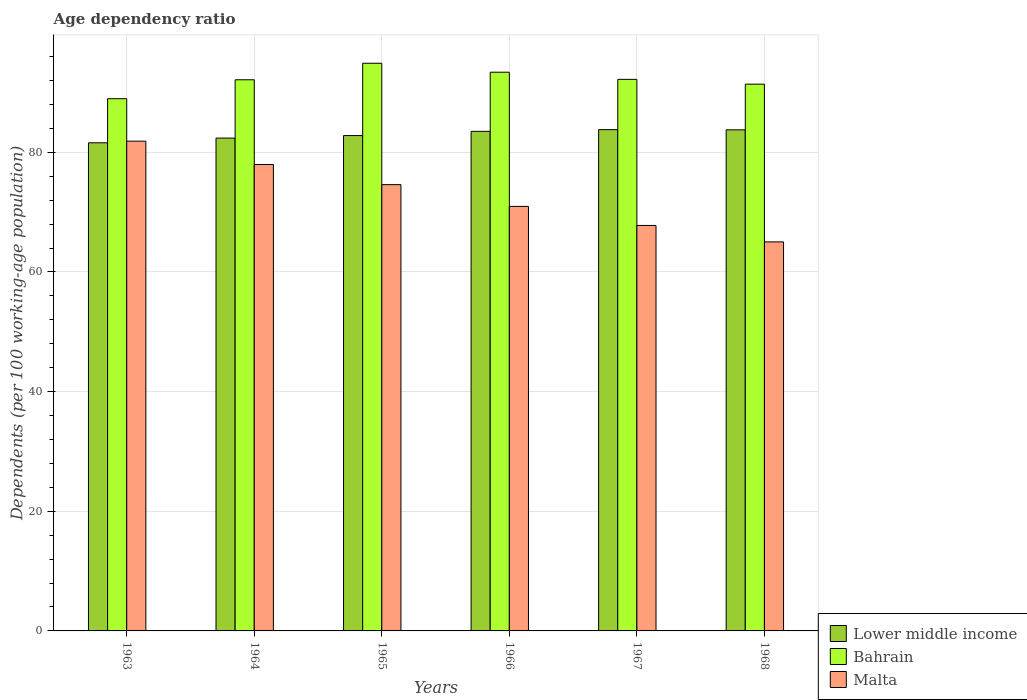How many different coloured bars are there?
Offer a very short reply. 3. How many bars are there on the 5th tick from the right?
Give a very brief answer. 3. What is the label of the 4th group of bars from the left?
Offer a terse response. 1966. What is the age dependency ratio in in Lower middle income in 1967?
Offer a very short reply. 83.79. Across all years, what is the maximum age dependency ratio in in Lower middle income?
Your response must be concise. 83.79. Across all years, what is the minimum age dependency ratio in in Lower middle income?
Keep it short and to the point. 81.59. In which year was the age dependency ratio in in Lower middle income maximum?
Make the answer very short. 1967. What is the total age dependency ratio in in Malta in the graph?
Your answer should be very brief. 438.16. What is the difference between the age dependency ratio in in Bahrain in 1963 and that in 1965?
Give a very brief answer. -5.93. What is the difference between the age dependency ratio in in Malta in 1968 and the age dependency ratio in in Bahrain in 1963?
Your answer should be compact. -23.93. What is the average age dependency ratio in in Malta per year?
Offer a terse response. 73.03. In the year 1964, what is the difference between the age dependency ratio in in Malta and age dependency ratio in in Lower middle income?
Offer a very short reply. -4.41. What is the ratio of the age dependency ratio in in Lower middle income in 1967 to that in 1968?
Make the answer very short. 1. What is the difference between the highest and the second highest age dependency ratio in in Bahrain?
Offer a very short reply. 1.5. What is the difference between the highest and the lowest age dependency ratio in in Malta?
Keep it short and to the point. 16.84. In how many years, is the age dependency ratio in in Lower middle income greater than the average age dependency ratio in in Lower middle income taken over all years?
Make the answer very short. 3. Is the sum of the age dependency ratio in in Lower middle income in 1965 and 1966 greater than the maximum age dependency ratio in in Bahrain across all years?
Provide a succinct answer. Yes. What does the 2nd bar from the left in 1965 represents?
Provide a succinct answer. Bahrain. What does the 3rd bar from the right in 1966 represents?
Ensure brevity in your answer.  Lower middle income. Are all the bars in the graph horizontal?
Make the answer very short. No. What is the difference between two consecutive major ticks on the Y-axis?
Make the answer very short. 20. Does the graph contain grids?
Provide a succinct answer. Yes. How are the legend labels stacked?
Offer a very short reply. Vertical. What is the title of the graph?
Your response must be concise. Age dependency ratio. Does "Morocco" appear as one of the legend labels in the graph?
Your answer should be very brief. No. What is the label or title of the Y-axis?
Keep it short and to the point. Dependents (per 100 working-age population). What is the Dependents (per 100 working-age population) of Lower middle income in 1963?
Give a very brief answer. 81.59. What is the Dependents (per 100 working-age population) of Bahrain in 1963?
Make the answer very short. 88.95. What is the Dependents (per 100 working-age population) in Malta in 1963?
Offer a terse response. 81.86. What is the Dependents (per 100 working-age population) in Lower middle income in 1964?
Provide a succinct answer. 82.37. What is the Dependents (per 100 working-age population) of Bahrain in 1964?
Ensure brevity in your answer.  92.12. What is the Dependents (per 100 working-age population) of Malta in 1964?
Provide a succinct answer. 77.96. What is the Dependents (per 100 working-age population) in Lower middle income in 1965?
Ensure brevity in your answer.  82.79. What is the Dependents (per 100 working-age population) in Bahrain in 1965?
Keep it short and to the point. 94.88. What is the Dependents (per 100 working-age population) of Malta in 1965?
Make the answer very short. 74.59. What is the Dependents (per 100 working-age population) of Lower middle income in 1966?
Your response must be concise. 83.5. What is the Dependents (per 100 working-age population) of Bahrain in 1966?
Offer a terse response. 93.38. What is the Dependents (per 100 working-age population) of Malta in 1966?
Offer a very short reply. 70.96. What is the Dependents (per 100 working-age population) in Lower middle income in 1967?
Make the answer very short. 83.79. What is the Dependents (per 100 working-age population) in Bahrain in 1967?
Provide a succinct answer. 92.19. What is the Dependents (per 100 working-age population) of Malta in 1967?
Make the answer very short. 67.77. What is the Dependents (per 100 working-age population) of Lower middle income in 1968?
Offer a terse response. 83.75. What is the Dependents (per 100 working-age population) in Bahrain in 1968?
Your answer should be very brief. 91.39. What is the Dependents (per 100 working-age population) of Malta in 1968?
Ensure brevity in your answer.  65.02. Across all years, what is the maximum Dependents (per 100 working-age population) of Lower middle income?
Your answer should be compact. 83.79. Across all years, what is the maximum Dependents (per 100 working-age population) in Bahrain?
Give a very brief answer. 94.88. Across all years, what is the maximum Dependents (per 100 working-age population) in Malta?
Ensure brevity in your answer.  81.86. Across all years, what is the minimum Dependents (per 100 working-age population) of Lower middle income?
Provide a short and direct response. 81.59. Across all years, what is the minimum Dependents (per 100 working-age population) in Bahrain?
Your answer should be very brief. 88.95. Across all years, what is the minimum Dependents (per 100 working-age population) in Malta?
Provide a succinct answer. 65.02. What is the total Dependents (per 100 working-age population) in Lower middle income in the graph?
Provide a succinct answer. 497.79. What is the total Dependents (per 100 working-age population) in Bahrain in the graph?
Ensure brevity in your answer.  552.91. What is the total Dependents (per 100 working-age population) of Malta in the graph?
Your answer should be compact. 438.16. What is the difference between the Dependents (per 100 working-age population) of Lower middle income in 1963 and that in 1964?
Offer a terse response. -0.79. What is the difference between the Dependents (per 100 working-age population) in Bahrain in 1963 and that in 1964?
Your answer should be very brief. -3.17. What is the difference between the Dependents (per 100 working-age population) of Malta in 1963 and that in 1964?
Give a very brief answer. 3.9. What is the difference between the Dependents (per 100 working-age population) of Lower middle income in 1963 and that in 1965?
Give a very brief answer. -1.21. What is the difference between the Dependents (per 100 working-age population) in Bahrain in 1963 and that in 1965?
Ensure brevity in your answer.  -5.93. What is the difference between the Dependents (per 100 working-age population) in Malta in 1963 and that in 1965?
Make the answer very short. 7.27. What is the difference between the Dependents (per 100 working-age population) of Lower middle income in 1963 and that in 1966?
Ensure brevity in your answer.  -1.91. What is the difference between the Dependents (per 100 working-age population) in Bahrain in 1963 and that in 1966?
Keep it short and to the point. -4.43. What is the difference between the Dependents (per 100 working-age population) of Malta in 1963 and that in 1966?
Provide a short and direct response. 10.9. What is the difference between the Dependents (per 100 working-age population) in Lower middle income in 1963 and that in 1967?
Your answer should be very brief. -2.2. What is the difference between the Dependents (per 100 working-age population) of Bahrain in 1963 and that in 1967?
Make the answer very short. -3.24. What is the difference between the Dependents (per 100 working-age population) of Malta in 1963 and that in 1967?
Provide a short and direct response. 14.09. What is the difference between the Dependents (per 100 working-age population) of Lower middle income in 1963 and that in 1968?
Offer a very short reply. -2.17. What is the difference between the Dependents (per 100 working-age population) of Bahrain in 1963 and that in 1968?
Your answer should be very brief. -2.43. What is the difference between the Dependents (per 100 working-age population) of Malta in 1963 and that in 1968?
Offer a terse response. 16.84. What is the difference between the Dependents (per 100 working-age population) in Lower middle income in 1964 and that in 1965?
Your response must be concise. -0.42. What is the difference between the Dependents (per 100 working-age population) of Bahrain in 1964 and that in 1965?
Provide a short and direct response. -2.76. What is the difference between the Dependents (per 100 working-age population) in Malta in 1964 and that in 1965?
Ensure brevity in your answer.  3.37. What is the difference between the Dependents (per 100 working-age population) of Lower middle income in 1964 and that in 1966?
Your response must be concise. -1.13. What is the difference between the Dependents (per 100 working-age population) in Bahrain in 1964 and that in 1966?
Ensure brevity in your answer.  -1.26. What is the difference between the Dependents (per 100 working-age population) in Malta in 1964 and that in 1966?
Keep it short and to the point. 7.01. What is the difference between the Dependents (per 100 working-age population) of Lower middle income in 1964 and that in 1967?
Your response must be concise. -1.41. What is the difference between the Dependents (per 100 working-age population) of Bahrain in 1964 and that in 1967?
Offer a very short reply. -0.07. What is the difference between the Dependents (per 100 working-age population) in Malta in 1964 and that in 1967?
Offer a very short reply. 10.19. What is the difference between the Dependents (per 100 working-age population) in Lower middle income in 1964 and that in 1968?
Your answer should be compact. -1.38. What is the difference between the Dependents (per 100 working-age population) in Bahrain in 1964 and that in 1968?
Provide a short and direct response. 0.73. What is the difference between the Dependents (per 100 working-age population) in Malta in 1964 and that in 1968?
Ensure brevity in your answer.  12.94. What is the difference between the Dependents (per 100 working-age population) of Lower middle income in 1965 and that in 1966?
Ensure brevity in your answer.  -0.71. What is the difference between the Dependents (per 100 working-age population) in Bahrain in 1965 and that in 1966?
Offer a terse response. 1.5. What is the difference between the Dependents (per 100 working-age population) in Malta in 1965 and that in 1966?
Give a very brief answer. 3.64. What is the difference between the Dependents (per 100 working-age population) of Lower middle income in 1965 and that in 1967?
Offer a terse response. -0.99. What is the difference between the Dependents (per 100 working-age population) of Bahrain in 1965 and that in 1967?
Your answer should be compact. 2.69. What is the difference between the Dependents (per 100 working-age population) in Malta in 1965 and that in 1967?
Give a very brief answer. 6.82. What is the difference between the Dependents (per 100 working-age population) in Lower middle income in 1965 and that in 1968?
Offer a very short reply. -0.96. What is the difference between the Dependents (per 100 working-age population) of Bahrain in 1965 and that in 1968?
Your response must be concise. 3.49. What is the difference between the Dependents (per 100 working-age population) in Malta in 1965 and that in 1968?
Ensure brevity in your answer.  9.57. What is the difference between the Dependents (per 100 working-age population) of Lower middle income in 1966 and that in 1967?
Ensure brevity in your answer.  -0.29. What is the difference between the Dependents (per 100 working-age population) of Bahrain in 1966 and that in 1967?
Your response must be concise. 1.19. What is the difference between the Dependents (per 100 working-age population) in Malta in 1966 and that in 1967?
Your answer should be very brief. 3.18. What is the difference between the Dependents (per 100 working-age population) of Lower middle income in 1966 and that in 1968?
Offer a very short reply. -0.25. What is the difference between the Dependents (per 100 working-age population) in Bahrain in 1966 and that in 1968?
Ensure brevity in your answer.  2. What is the difference between the Dependents (per 100 working-age population) in Malta in 1966 and that in 1968?
Your answer should be very brief. 5.93. What is the difference between the Dependents (per 100 working-age population) in Lower middle income in 1967 and that in 1968?
Provide a succinct answer. 0.04. What is the difference between the Dependents (per 100 working-age population) in Bahrain in 1967 and that in 1968?
Your response must be concise. 0.8. What is the difference between the Dependents (per 100 working-age population) of Malta in 1967 and that in 1968?
Give a very brief answer. 2.75. What is the difference between the Dependents (per 100 working-age population) of Lower middle income in 1963 and the Dependents (per 100 working-age population) of Bahrain in 1964?
Provide a succinct answer. -10.53. What is the difference between the Dependents (per 100 working-age population) of Lower middle income in 1963 and the Dependents (per 100 working-age population) of Malta in 1964?
Keep it short and to the point. 3.63. What is the difference between the Dependents (per 100 working-age population) of Bahrain in 1963 and the Dependents (per 100 working-age population) of Malta in 1964?
Offer a very short reply. 10.99. What is the difference between the Dependents (per 100 working-age population) of Lower middle income in 1963 and the Dependents (per 100 working-age population) of Bahrain in 1965?
Make the answer very short. -13.29. What is the difference between the Dependents (per 100 working-age population) in Lower middle income in 1963 and the Dependents (per 100 working-age population) in Malta in 1965?
Offer a terse response. 6.99. What is the difference between the Dependents (per 100 working-age population) of Bahrain in 1963 and the Dependents (per 100 working-age population) of Malta in 1965?
Provide a short and direct response. 14.36. What is the difference between the Dependents (per 100 working-age population) of Lower middle income in 1963 and the Dependents (per 100 working-age population) of Bahrain in 1966?
Offer a terse response. -11.8. What is the difference between the Dependents (per 100 working-age population) of Lower middle income in 1963 and the Dependents (per 100 working-age population) of Malta in 1966?
Offer a very short reply. 10.63. What is the difference between the Dependents (per 100 working-age population) in Bahrain in 1963 and the Dependents (per 100 working-age population) in Malta in 1966?
Your answer should be compact. 18. What is the difference between the Dependents (per 100 working-age population) of Lower middle income in 1963 and the Dependents (per 100 working-age population) of Bahrain in 1967?
Offer a terse response. -10.6. What is the difference between the Dependents (per 100 working-age population) in Lower middle income in 1963 and the Dependents (per 100 working-age population) in Malta in 1967?
Your answer should be very brief. 13.81. What is the difference between the Dependents (per 100 working-age population) of Bahrain in 1963 and the Dependents (per 100 working-age population) of Malta in 1967?
Your answer should be compact. 21.18. What is the difference between the Dependents (per 100 working-age population) of Lower middle income in 1963 and the Dependents (per 100 working-age population) of Bahrain in 1968?
Your answer should be very brief. -9.8. What is the difference between the Dependents (per 100 working-age population) in Lower middle income in 1963 and the Dependents (per 100 working-age population) in Malta in 1968?
Offer a terse response. 16.56. What is the difference between the Dependents (per 100 working-age population) of Bahrain in 1963 and the Dependents (per 100 working-age population) of Malta in 1968?
Offer a very short reply. 23.93. What is the difference between the Dependents (per 100 working-age population) in Lower middle income in 1964 and the Dependents (per 100 working-age population) in Bahrain in 1965?
Make the answer very short. -12.51. What is the difference between the Dependents (per 100 working-age population) in Lower middle income in 1964 and the Dependents (per 100 working-age population) in Malta in 1965?
Provide a short and direct response. 7.78. What is the difference between the Dependents (per 100 working-age population) in Bahrain in 1964 and the Dependents (per 100 working-age population) in Malta in 1965?
Make the answer very short. 17.53. What is the difference between the Dependents (per 100 working-age population) in Lower middle income in 1964 and the Dependents (per 100 working-age population) in Bahrain in 1966?
Your response must be concise. -11.01. What is the difference between the Dependents (per 100 working-age population) of Lower middle income in 1964 and the Dependents (per 100 working-age population) of Malta in 1966?
Offer a very short reply. 11.42. What is the difference between the Dependents (per 100 working-age population) in Bahrain in 1964 and the Dependents (per 100 working-age population) in Malta in 1966?
Give a very brief answer. 21.16. What is the difference between the Dependents (per 100 working-age population) of Lower middle income in 1964 and the Dependents (per 100 working-age population) of Bahrain in 1967?
Provide a succinct answer. -9.82. What is the difference between the Dependents (per 100 working-age population) of Lower middle income in 1964 and the Dependents (per 100 working-age population) of Malta in 1967?
Make the answer very short. 14.6. What is the difference between the Dependents (per 100 working-age population) of Bahrain in 1964 and the Dependents (per 100 working-age population) of Malta in 1967?
Provide a short and direct response. 24.35. What is the difference between the Dependents (per 100 working-age population) of Lower middle income in 1964 and the Dependents (per 100 working-age population) of Bahrain in 1968?
Ensure brevity in your answer.  -9.01. What is the difference between the Dependents (per 100 working-age population) of Lower middle income in 1964 and the Dependents (per 100 working-age population) of Malta in 1968?
Offer a terse response. 17.35. What is the difference between the Dependents (per 100 working-age population) of Bahrain in 1964 and the Dependents (per 100 working-age population) of Malta in 1968?
Your answer should be very brief. 27.1. What is the difference between the Dependents (per 100 working-age population) of Lower middle income in 1965 and the Dependents (per 100 working-age population) of Bahrain in 1966?
Provide a succinct answer. -10.59. What is the difference between the Dependents (per 100 working-age population) of Lower middle income in 1965 and the Dependents (per 100 working-age population) of Malta in 1966?
Give a very brief answer. 11.84. What is the difference between the Dependents (per 100 working-age population) of Bahrain in 1965 and the Dependents (per 100 working-age population) of Malta in 1966?
Your response must be concise. 23.92. What is the difference between the Dependents (per 100 working-age population) in Lower middle income in 1965 and the Dependents (per 100 working-age population) in Bahrain in 1967?
Make the answer very short. -9.4. What is the difference between the Dependents (per 100 working-age population) in Lower middle income in 1965 and the Dependents (per 100 working-age population) in Malta in 1967?
Make the answer very short. 15.02. What is the difference between the Dependents (per 100 working-age population) of Bahrain in 1965 and the Dependents (per 100 working-age population) of Malta in 1967?
Provide a succinct answer. 27.11. What is the difference between the Dependents (per 100 working-age population) of Lower middle income in 1965 and the Dependents (per 100 working-age population) of Bahrain in 1968?
Offer a very short reply. -8.59. What is the difference between the Dependents (per 100 working-age population) in Lower middle income in 1965 and the Dependents (per 100 working-age population) in Malta in 1968?
Provide a short and direct response. 17.77. What is the difference between the Dependents (per 100 working-age population) of Bahrain in 1965 and the Dependents (per 100 working-age population) of Malta in 1968?
Give a very brief answer. 29.86. What is the difference between the Dependents (per 100 working-age population) of Lower middle income in 1966 and the Dependents (per 100 working-age population) of Bahrain in 1967?
Give a very brief answer. -8.69. What is the difference between the Dependents (per 100 working-age population) in Lower middle income in 1966 and the Dependents (per 100 working-age population) in Malta in 1967?
Your response must be concise. 15.73. What is the difference between the Dependents (per 100 working-age population) of Bahrain in 1966 and the Dependents (per 100 working-age population) of Malta in 1967?
Your answer should be very brief. 25.61. What is the difference between the Dependents (per 100 working-age population) in Lower middle income in 1966 and the Dependents (per 100 working-age population) in Bahrain in 1968?
Make the answer very short. -7.88. What is the difference between the Dependents (per 100 working-age population) in Lower middle income in 1966 and the Dependents (per 100 working-age population) in Malta in 1968?
Make the answer very short. 18.48. What is the difference between the Dependents (per 100 working-age population) of Bahrain in 1966 and the Dependents (per 100 working-age population) of Malta in 1968?
Make the answer very short. 28.36. What is the difference between the Dependents (per 100 working-age population) of Lower middle income in 1967 and the Dependents (per 100 working-age population) of Bahrain in 1968?
Keep it short and to the point. -7.6. What is the difference between the Dependents (per 100 working-age population) in Lower middle income in 1967 and the Dependents (per 100 working-age population) in Malta in 1968?
Give a very brief answer. 18.76. What is the difference between the Dependents (per 100 working-age population) of Bahrain in 1967 and the Dependents (per 100 working-age population) of Malta in 1968?
Make the answer very short. 27.17. What is the average Dependents (per 100 working-age population) in Lower middle income per year?
Give a very brief answer. 82.97. What is the average Dependents (per 100 working-age population) in Bahrain per year?
Give a very brief answer. 92.15. What is the average Dependents (per 100 working-age population) in Malta per year?
Keep it short and to the point. 73.03. In the year 1963, what is the difference between the Dependents (per 100 working-age population) of Lower middle income and Dependents (per 100 working-age population) of Bahrain?
Your answer should be very brief. -7.37. In the year 1963, what is the difference between the Dependents (per 100 working-age population) in Lower middle income and Dependents (per 100 working-age population) in Malta?
Your response must be concise. -0.27. In the year 1963, what is the difference between the Dependents (per 100 working-age population) in Bahrain and Dependents (per 100 working-age population) in Malta?
Give a very brief answer. 7.1. In the year 1964, what is the difference between the Dependents (per 100 working-age population) of Lower middle income and Dependents (per 100 working-age population) of Bahrain?
Ensure brevity in your answer.  -9.75. In the year 1964, what is the difference between the Dependents (per 100 working-age population) in Lower middle income and Dependents (per 100 working-age population) in Malta?
Keep it short and to the point. 4.41. In the year 1964, what is the difference between the Dependents (per 100 working-age population) in Bahrain and Dependents (per 100 working-age population) in Malta?
Your response must be concise. 14.16. In the year 1965, what is the difference between the Dependents (per 100 working-age population) of Lower middle income and Dependents (per 100 working-age population) of Bahrain?
Offer a very short reply. -12.09. In the year 1965, what is the difference between the Dependents (per 100 working-age population) of Lower middle income and Dependents (per 100 working-age population) of Malta?
Offer a very short reply. 8.2. In the year 1965, what is the difference between the Dependents (per 100 working-age population) in Bahrain and Dependents (per 100 working-age population) in Malta?
Your answer should be very brief. 20.29. In the year 1966, what is the difference between the Dependents (per 100 working-age population) of Lower middle income and Dependents (per 100 working-age population) of Bahrain?
Provide a short and direct response. -9.88. In the year 1966, what is the difference between the Dependents (per 100 working-age population) of Lower middle income and Dependents (per 100 working-age population) of Malta?
Keep it short and to the point. 12.54. In the year 1966, what is the difference between the Dependents (per 100 working-age population) of Bahrain and Dependents (per 100 working-age population) of Malta?
Your answer should be compact. 22.43. In the year 1967, what is the difference between the Dependents (per 100 working-age population) of Lower middle income and Dependents (per 100 working-age population) of Bahrain?
Give a very brief answer. -8.4. In the year 1967, what is the difference between the Dependents (per 100 working-age population) in Lower middle income and Dependents (per 100 working-age population) in Malta?
Your answer should be compact. 16.02. In the year 1967, what is the difference between the Dependents (per 100 working-age population) of Bahrain and Dependents (per 100 working-age population) of Malta?
Your response must be concise. 24.42. In the year 1968, what is the difference between the Dependents (per 100 working-age population) of Lower middle income and Dependents (per 100 working-age population) of Bahrain?
Your response must be concise. -7.63. In the year 1968, what is the difference between the Dependents (per 100 working-age population) of Lower middle income and Dependents (per 100 working-age population) of Malta?
Make the answer very short. 18.73. In the year 1968, what is the difference between the Dependents (per 100 working-age population) of Bahrain and Dependents (per 100 working-age population) of Malta?
Keep it short and to the point. 26.36. What is the ratio of the Dependents (per 100 working-age population) of Bahrain in 1963 to that in 1964?
Offer a very short reply. 0.97. What is the ratio of the Dependents (per 100 working-age population) of Lower middle income in 1963 to that in 1965?
Provide a succinct answer. 0.99. What is the ratio of the Dependents (per 100 working-age population) of Bahrain in 1963 to that in 1965?
Ensure brevity in your answer.  0.94. What is the ratio of the Dependents (per 100 working-age population) in Malta in 1963 to that in 1965?
Keep it short and to the point. 1.1. What is the ratio of the Dependents (per 100 working-age population) of Lower middle income in 1963 to that in 1966?
Your answer should be very brief. 0.98. What is the ratio of the Dependents (per 100 working-age population) in Bahrain in 1963 to that in 1966?
Make the answer very short. 0.95. What is the ratio of the Dependents (per 100 working-age population) in Malta in 1963 to that in 1966?
Ensure brevity in your answer.  1.15. What is the ratio of the Dependents (per 100 working-age population) in Lower middle income in 1963 to that in 1967?
Offer a terse response. 0.97. What is the ratio of the Dependents (per 100 working-age population) of Bahrain in 1963 to that in 1967?
Your answer should be very brief. 0.96. What is the ratio of the Dependents (per 100 working-age population) in Malta in 1963 to that in 1967?
Offer a very short reply. 1.21. What is the ratio of the Dependents (per 100 working-age population) in Lower middle income in 1963 to that in 1968?
Offer a terse response. 0.97. What is the ratio of the Dependents (per 100 working-age population) of Bahrain in 1963 to that in 1968?
Provide a short and direct response. 0.97. What is the ratio of the Dependents (per 100 working-age population) of Malta in 1963 to that in 1968?
Keep it short and to the point. 1.26. What is the ratio of the Dependents (per 100 working-age population) of Lower middle income in 1964 to that in 1965?
Your answer should be compact. 0.99. What is the ratio of the Dependents (per 100 working-age population) of Bahrain in 1964 to that in 1965?
Give a very brief answer. 0.97. What is the ratio of the Dependents (per 100 working-age population) in Malta in 1964 to that in 1965?
Keep it short and to the point. 1.05. What is the ratio of the Dependents (per 100 working-age population) in Lower middle income in 1964 to that in 1966?
Ensure brevity in your answer.  0.99. What is the ratio of the Dependents (per 100 working-age population) in Bahrain in 1964 to that in 1966?
Provide a short and direct response. 0.99. What is the ratio of the Dependents (per 100 working-age population) in Malta in 1964 to that in 1966?
Your response must be concise. 1.1. What is the ratio of the Dependents (per 100 working-age population) of Lower middle income in 1964 to that in 1967?
Offer a very short reply. 0.98. What is the ratio of the Dependents (per 100 working-age population) in Bahrain in 1964 to that in 1967?
Offer a very short reply. 1. What is the ratio of the Dependents (per 100 working-age population) of Malta in 1964 to that in 1967?
Make the answer very short. 1.15. What is the ratio of the Dependents (per 100 working-age population) in Lower middle income in 1964 to that in 1968?
Your answer should be compact. 0.98. What is the ratio of the Dependents (per 100 working-age population) in Bahrain in 1964 to that in 1968?
Offer a very short reply. 1.01. What is the ratio of the Dependents (per 100 working-age population) in Malta in 1964 to that in 1968?
Keep it short and to the point. 1.2. What is the ratio of the Dependents (per 100 working-age population) of Bahrain in 1965 to that in 1966?
Offer a very short reply. 1.02. What is the ratio of the Dependents (per 100 working-age population) in Malta in 1965 to that in 1966?
Make the answer very short. 1.05. What is the ratio of the Dependents (per 100 working-age population) of Lower middle income in 1965 to that in 1967?
Offer a very short reply. 0.99. What is the ratio of the Dependents (per 100 working-age population) in Bahrain in 1965 to that in 1967?
Ensure brevity in your answer.  1.03. What is the ratio of the Dependents (per 100 working-age population) of Malta in 1965 to that in 1967?
Your answer should be compact. 1.1. What is the ratio of the Dependents (per 100 working-age population) of Bahrain in 1965 to that in 1968?
Provide a succinct answer. 1.04. What is the ratio of the Dependents (per 100 working-age population) of Malta in 1965 to that in 1968?
Your answer should be very brief. 1.15. What is the ratio of the Dependents (per 100 working-age population) of Lower middle income in 1966 to that in 1967?
Your answer should be very brief. 1. What is the ratio of the Dependents (per 100 working-age population) of Bahrain in 1966 to that in 1967?
Ensure brevity in your answer.  1.01. What is the ratio of the Dependents (per 100 working-age population) of Malta in 1966 to that in 1967?
Give a very brief answer. 1.05. What is the ratio of the Dependents (per 100 working-age population) of Bahrain in 1966 to that in 1968?
Offer a very short reply. 1.02. What is the ratio of the Dependents (per 100 working-age population) in Malta in 1966 to that in 1968?
Keep it short and to the point. 1.09. What is the ratio of the Dependents (per 100 working-age population) in Lower middle income in 1967 to that in 1968?
Offer a very short reply. 1. What is the ratio of the Dependents (per 100 working-age population) of Bahrain in 1967 to that in 1968?
Make the answer very short. 1.01. What is the ratio of the Dependents (per 100 working-age population) in Malta in 1967 to that in 1968?
Offer a terse response. 1.04. What is the difference between the highest and the second highest Dependents (per 100 working-age population) in Lower middle income?
Make the answer very short. 0.04. What is the difference between the highest and the second highest Dependents (per 100 working-age population) of Bahrain?
Your response must be concise. 1.5. What is the difference between the highest and the second highest Dependents (per 100 working-age population) of Malta?
Keep it short and to the point. 3.9. What is the difference between the highest and the lowest Dependents (per 100 working-age population) of Lower middle income?
Offer a terse response. 2.2. What is the difference between the highest and the lowest Dependents (per 100 working-age population) of Bahrain?
Provide a short and direct response. 5.93. What is the difference between the highest and the lowest Dependents (per 100 working-age population) of Malta?
Make the answer very short. 16.84. 